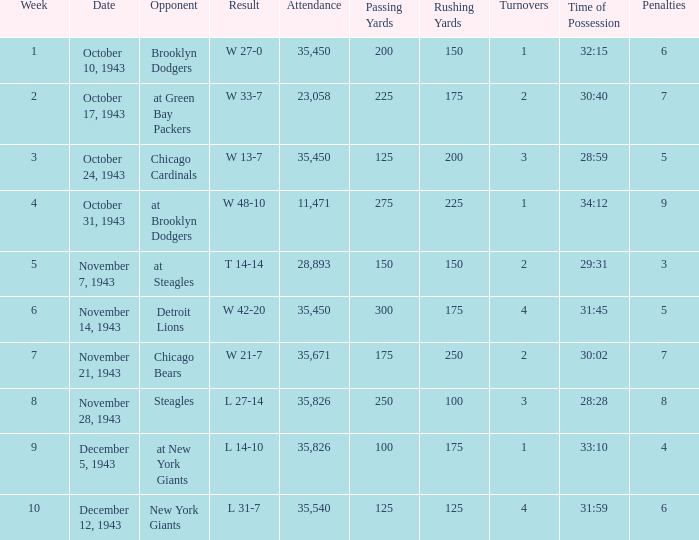How many attendances have w 48-10 as the result? 11471.0. 